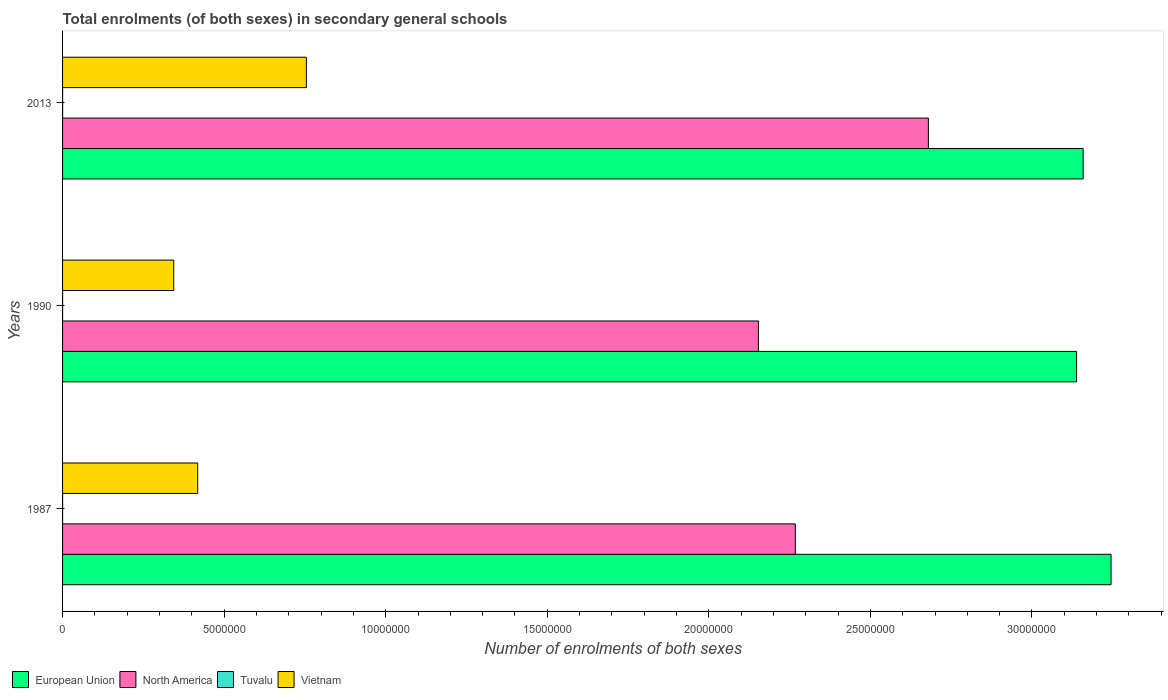How many different coloured bars are there?
Make the answer very short. 4. How many groups of bars are there?
Offer a terse response. 3. Are the number of bars on each tick of the Y-axis equal?
Make the answer very short. Yes. How many bars are there on the 2nd tick from the bottom?
Offer a terse response. 4. In how many cases, is the number of bars for a given year not equal to the number of legend labels?
Provide a succinct answer. 0. What is the number of enrolments in secondary schools in Vietnam in 1987?
Your answer should be compact. 4.18e+06. Across all years, what is the maximum number of enrolments in secondary schools in Vietnam?
Offer a very short reply. 7.55e+06. Across all years, what is the minimum number of enrolments in secondary schools in North America?
Offer a very short reply. 2.15e+07. In which year was the number of enrolments in secondary schools in European Union maximum?
Provide a succinct answer. 1987. In which year was the number of enrolments in secondary schools in European Union minimum?
Offer a terse response. 1990. What is the total number of enrolments in secondary schools in European Union in the graph?
Provide a short and direct response. 9.54e+07. What is the difference between the number of enrolments in secondary schools in North America in 1987 and that in 2013?
Your answer should be very brief. -4.12e+06. What is the difference between the number of enrolments in secondary schools in Tuvalu in 1990 and the number of enrolments in secondary schools in North America in 2013?
Make the answer very short. -2.68e+07. What is the average number of enrolments in secondary schools in Vietnam per year?
Make the answer very short. 5.06e+06. In the year 2013, what is the difference between the number of enrolments in secondary schools in North America and number of enrolments in secondary schools in Tuvalu?
Your answer should be compact. 2.68e+07. In how many years, is the number of enrolments in secondary schools in North America greater than 3000000 ?
Your answer should be very brief. 3. What is the ratio of the number of enrolments in secondary schools in European Union in 1987 to that in 1990?
Offer a terse response. 1.03. What is the difference between the highest and the second highest number of enrolments in secondary schools in Vietnam?
Your answer should be very brief. 3.36e+06. What is the difference between the highest and the lowest number of enrolments in secondary schools in North America?
Your answer should be very brief. 5.26e+06. In how many years, is the number of enrolments in secondary schools in Vietnam greater than the average number of enrolments in secondary schools in Vietnam taken over all years?
Offer a very short reply. 1. What does the 4th bar from the top in 1987 represents?
Provide a succinct answer. European Union. Is it the case that in every year, the sum of the number of enrolments in secondary schools in Tuvalu and number of enrolments in secondary schools in North America is greater than the number of enrolments in secondary schools in Vietnam?
Give a very brief answer. Yes. Are all the bars in the graph horizontal?
Make the answer very short. Yes. Does the graph contain grids?
Make the answer very short. No. What is the title of the graph?
Offer a very short reply. Total enrolments (of both sexes) in secondary general schools. What is the label or title of the X-axis?
Provide a short and direct response. Number of enrolments of both sexes. What is the Number of enrolments of both sexes in European Union in 1987?
Ensure brevity in your answer.  3.24e+07. What is the Number of enrolments of both sexes in North America in 1987?
Offer a very short reply. 2.27e+07. What is the Number of enrolments of both sexes of Tuvalu in 1987?
Give a very brief answer. 584. What is the Number of enrolments of both sexes of Vietnam in 1987?
Ensure brevity in your answer.  4.18e+06. What is the Number of enrolments of both sexes of European Union in 1990?
Your answer should be very brief. 3.14e+07. What is the Number of enrolments of both sexes in North America in 1990?
Your answer should be compact. 2.15e+07. What is the Number of enrolments of both sexes of Tuvalu in 1990?
Your response must be concise. 594. What is the Number of enrolments of both sexes in Vietnam in 1990?
Provide a short and direct response. 3.44e+06. What is the Number of enrolments of both sexes of European Union in 2013?
Your answer should be compact. 3.16e+07. What is the Number of enrolments of both sexes in North America in 2013?
Keep it short and to the point. 2.68e+07. What is the Number of enrolments of both sexes in Tuvalu in 2013?
Make the answer very short. 1181. What is the Number of enrolments of both sexes in Vietnam in 2013?
Provide a succinct answer. 7.55e+06. Across all years, what is the maximum Number of enrolments of both sexes of European Union?
Offer a very short reply. 3.24e+07. Across all years, what is the maximum Number of enrolments of both sexes in North America?
Your answer should be very brief. 2.68e+07. Across all years, what is the maximum Number of enrolments of both sexes in Tuvalu?
Your answer should be very brief. 1181. Across all years, what is the maximum Number of enrolments of both sexes in Vietnam?
Ensure brevity in your answer.  7.55e+06. Across all years, what is the minimum Number of enrolments of both sexes in European Union?
Your answer should be very brief. 3.14e+07. Across all years, what is the minimum Number of enrolments of both sexes of North America?
Make the answer very short. 2.15e+07. Across all years, what is the minimum Number of enrolments of both sexes of Tuvalu?
Offer a very short reply. 584. Across all years, what is the minimum Number of enrolments of both sexes in Vietnam?
Ensure brevity in your answer.  3.44e+06. What is the total Number of enrolments of both sexes of European Union in the graph?
Provide a succinct answer. 9.54e+07. What is the total Number of enrolments of both sexes in North America in the graph?
Keep it short and to the point. 7.10e+07. What is the total Number of enrolments of both sexes of Tuvalu in the graph?
Your answer should be compact. 2359. What is the total Number of enrolments of both sexes in Vietnam in the graph?
Make the answer very short. 1.52e+07. What is the difference between the Number of enrolments of both sexes of European Union in 1987 and that in 1990?
Your answer should be compact. 1.07e+06. What is the difference between the Number of enrolments of both sexes in North America in 1987 and that in 1990?
Provide a short and direct response. 1.14e+06. What is the difference between the Number of enrolments of both sexes of Tuvalu in 1987 and that in 1990?
Ensure brevity in your answer.  -10. What is the difference between the Number of enrolments of both sexes of Vietnam in 1987 and that in 1990?
Provide a succinct answer. 7.42e+05. What is the difference between the Number of enrolments of both sexes in European Union in 1987 and that in 2013?
Offer a terse response. 8.64e+05. What is the difference between the Number of enrolments of both sexes of North America in 1987 and that in 2013?
Provide a succinct answer. -4.12e+06. What is the difference between the Number of enrolments of both sexes in Tuvalu in 1987 and that in 2013?
Your response must be concise. -597. What is the difference between the Number of enrolments of both sexes of Vietnam in 1987 and that in 2013?
Provide a short and direct response. -3.36e+06. What is the difference between the Number of enrolments of both sexes in European Union in 1990 and that in 2013?
Your answer should be compact. -2.03e+05. What is the difference between the Number of enrolments of both sexes in North America in 1990 and that in 2013?
Offer a terse response. -5.26e+06. What is the difference between the Number of enrolments of both sexes in Tuvalu in 1990 and that in 2013?
Provide a short and direct response. -587. What is the difference between the Number of enrolments of both sexes in Vietnam in 1990 and that in 2013?
Your response must be concise. -4.10e+06. What is the difference between the Number of enrolments of both sexes of European Union in 1987 and the Number of enrolments of both sexes of North America in 1990?
Ensure brevity in your answer.  1.09e+07. What is the difference between the Number of enrolments of both sexes of European Union in 1987 and the Number of enrolments of both sexes of Tuvalu in 1990?
Provide a succinct answer. 3.24e+07. What is the difference between the Number of enrolments of both sexes of European Union in 1987 and the Number of enrolments of both sexes of Vietnam in 1990?
Offer a very short reply. 2.90e+07. What is the difference between the Number of enrolments of both sexes in North America in 1987 and the Number of enrolments of both sexes in Tuvalu in 1990?
Provide a succinct answer. 2.27e+07. What is the difference between the Number of enrolments of both sexes in North America in 1987 and the Number of enrolments of both sexes in Vietnam in 1990?
Your response must be concise. 1.92e+07. What is the difference between the Number of enrolments of both sexes of Tuvalu in 1987 and the Number of enrolments of both sexes of Vietnam in 1990?
Provide a succinct answer. -3.44e+06. What is the difference between the Number of enrolments of both sexes in European Union in 1987 and the Number of enrolments of both sexes in North America in 2013?
Your response must be concise. 5.65e+06. What is the difference between the Number of enrolments of both sexes of European Union in 1987 and the Number of enrolments of both sexes of Tuvalu in 2013?
Make the answer very short. 3.24e+07. What is the difference between the Number of enrolments of both sexes of European Union in 1987 and the Number of enrolments of both sexes of Vietnam in 2013?
Provide a short and direct response. 2.49e+07. What is the difference between the Number of enrolments of both sexes of North America in 1987 and the Number of enrolments of both sexes of Tuvalu in 2013?
Keep it short and to the point. 2.27e+07. What is the difference between the Number of enrolments of both sexes in North America in 1987 and the Number of enrolments of both sexes in Vietnam in 2013?
Your answer should be compact. 1.51e+07. What is the difference between the Number of enrolments of both sexes in Tuvalu in 1987 and the Number of enrolments of both sexes in Vietnam in 2013?
Your answer should be very brief. -7.54e+06. What is the difference between the Number of enrolments of both sexes of European Union in 1990 and the Number of enrolments of both sexes of North America in 2013?
Offer a very short reply. 4.59e+06. What is the difference between the Number of enrolments of both sexes in European Union in 1990 and the Number of enrolments of both sexes in Tuvalu in 2013?
Ensure brevity in your answer.  3.14e+07. What is the difference between the Number of enrolments of both sexes in European Union in 1990 and the Number of enrolments of both sexes in Vietnam in 2013?
Keep it short and to the point. 2.38e+07. What is the difference between the Number of enrolments of both sexes of North America in 1990 and the Number of enrolments of both sexes of Tuvalu in 2013?
Make the answer very short. 2.15e+07. What is the difference between the Number of enrolments of both sexes of North America in 1990 and the Number of enrolments of both sexes of Vietnam in 2013?
Your answer should be very brief. 1.40e+07. What is the difference between the Number of enrolments of both sexes in Tuvalu in 1990 and the Number of enrolments of both sexes in Vietnam in 2013?
Your response must be concise. -7.54e+06. What is the average Number of enrolments of both sexes in European Union per year?
Keep it short and to the point. 3.18e+07. What is the average Number of enrolments of both sexes of North America per year?
Your response must be concise. 2.37e+07. What is the average Number of enrolments of both sexes of Tuvalu per year?
Provide a short and direct response. 786.33. What is the average Number of enrolments of both sexes in Vietnam per year?
Your answer should be very brief. 5.06e+06. In the year 1987, what is the difference between the Number of enrolments of both sexes of European Union and Number of enrolments of both sexes of North America?
Make the answer very short. 9.77e+06. In the year 1987, what is the difference between the Number of enrolments of both sexes in European Union and Number of enrolments of both sexes in Tuvalu?
Your answer should be compact. 3.24e+07. In the year 1987, what is the difference between the Number of enrolments of both sexes in European Union and Number of enrolments of both sexes in Vietnam?
Provide a short and direct response. 2.83e+07. In the year 1987, what is the difference between the Number of enrolments of both sexes of North America and Number of enrolments of both sexes of Tuvalu?
Your answer should be compact. 2.27e+07. In the year 1987, what is the difference between the Number of enrolments of both sexes in North America and Number of enrolments of both sexes in Vietnam?
Ensure brevity in your answer.  1.85e+07. In the year 1987, what is the difference between the Number of enrolments of both sexes of Tuvalu and Number of enrolments of both sexes of Vietnam?
Make the answer very short. -4.18e+06. In the year 1990, what is the difference between the Number of enrolments of both sexes in European Union and Number of enrolments of both sexes in North America?
Keep it short and to the point. 9.85e+06. In the year 1990, what is the difference between the Number of enrolments of both sexes in European Union and Number of enrolments of both sexes in Tuvalu?
Your answer should be very brief. 3.14e+07. In the year 1990, what is the difference between the Number of enrolments of both sexes of European Union and Number of enrolments of both sexes of Vietnam?
Ensure brevity in your answer.  2.79e+07. In the year 1990, what is the difference between the Number of enrolments of both sexes in North America and Number of enrolments of both sexes in Tuvalu?
Ensure brevity in your answer.  2.15e+07. In the year 1990, what is the difference between the Number of enrolments of both sexes of North America and Number of enrolments of both sexes of Vietnam?
Provide a short and direct response. 1.81e+07. In the year 1990, what is the difference between the Number of enrolments of both sexes of Tuvalu and Number of enrolments of both sexes of Vietnam?
Your answer should be compact. -3.44e+06. In the year 2013, what is the difference between the Number of enrolments of both sexes in European Union and Number of enrolments of both sexes in North America?
Ensure brevity in your answer.  4.79e+06. In the year 2013, what is the difference between the Number of enrolments of both sexes of European Union and Number of enrolments of both sexes of Tuvalu?
Your answer should be very brief. 3.16e+07. In the year 2013, what is the difference between the Number of enrolments of both sexes of European Union and Number of enrolments of both sexes of Vietnam?
Give a very brief answer. 2.40e+07. In the year 2013, what is the difference between the Number of enrolments of both sexes in North America and Number of enrolments of both sexes in Tuvalu?
Keep it short and to the point. 2.68e+07. In the year 2013, what is the difference between the Number of enrolments of both sexes of North America and Number of enrolments of both sexes of Vietnam?
Ensure brevity in your answer.  1.92e+07. In the year 2013, what is the difference between the Number of enrolments of both sexes of Tuvalu and Number of enrolments of both sexes of Vietnam?
Ensure brevity in your answer.  -7.54e+06. What is the ratio of the Number of enrolments of both sexes of European Union in 1987 to that in 1990?
Ensure brevity in your answer.  1.03. What is the ratio of the Number of enrolments of both sexes in North America in 1987 to that in 1990?
Give a very brief answer. 1.05. What is the ratio of the Number of enrolments of both sexes in Tuvalu in 1987 to that in 1990?
Your response must be concise. 0.98. What is the ratio of the Number of enrolments of both sexes of Vietnam in 1987 to that in 1990?
Your answer should be compact. 1.22. What is the ratio of the Number of enrolments of both sexes of European Union in 1987 to that in 2013?
Your answer should be compact. 1.03. What is the ratio of the Number of enrolments of both sexes of North America in 1987 to that in 2013?
Make the answer very short. 0.85. What is the ratio of the Number of enrolments of both sexes of Tuvalu in 1987 to that in 2013?
Your answer should be very brief. 0.49. What is the ratio of the Number of enrolments of both sexes of Vietnam in 1987 to that in 2013?
Offer a terse response. 0.55. What is the ratio of the Number of enrolments of both sexes of North America in 1990 to that in 2013?
Your answer should be compact. 0.8. What is the ratio of the Number of enrolments of both sexes in Tuvalu in 1990 to that in 2013?
Your response must be concise. 0.5. What is the ratio of the Number of enrolments of both sexes of Vietnam in 1990 to that in 2013?
Your answer should be very brief. 0.46. What is the difference between the highest and the second highest Number of enrolments of both sexes of European Union?
Keep it short and to the point. 8.64e+05. What is the difference between the highest and the second highest Number of enrolments of both sexes in North America?
Give a very brief answer. 4.12e+06. What is the difference between the highest and the second highest Number of enrolments of both sexes of Tuvalu?
Your response must be concise. 587. What is the difference between the highest and the second highest Number of enrolments of both sexes of Vietnam?
Ensure brevity in your answer.  3.36e+06. What is the difference between the highest and the lowest Number of enrolments of both sexes in European Union?
Provide a succinct answer. 1.07e+06. What is the difference between the highest and the lowest Number of enrolments of both sexes of North America?
Your response must be concise. 5.26e+06. What is the difference between the highest and the lowest Number of enrolments of both sexes in Tuvalu?
Your response must be concise. 597. What is the difference between the highest and the lowest Number of enrolments of both sexes in Vietnam?
Make the answer very short. 4.10e+06. 